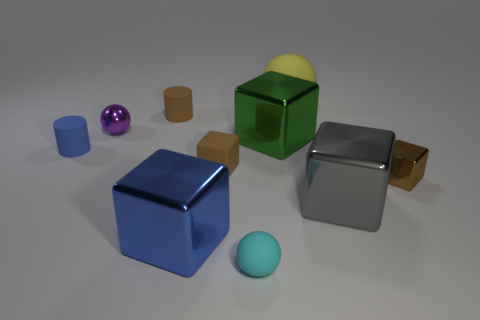Subtract all blue cubes. How many cubes are left? 4 Subtract all brown cylinders. How many cylinders are left? 1 Subtract all cylinders. How many objects are left? 8 Subtract 1 spheres. How many spheres are left? 2 Subtract all red balls. How many brown blocks are left? 2 Subtract all small brown rubber spheres. Subtract all blue matte cylinders. How many objects are left? 9 Add 9 gray things. How many gray things are left? 10 Add 10 brown matte spheres. How many brown matte spheres exist? 10 Subtract 0 red cylinders. How many objects are left? 10 Subtract all red balls. Subtract all yellow blocks. How many balls are left? 3 